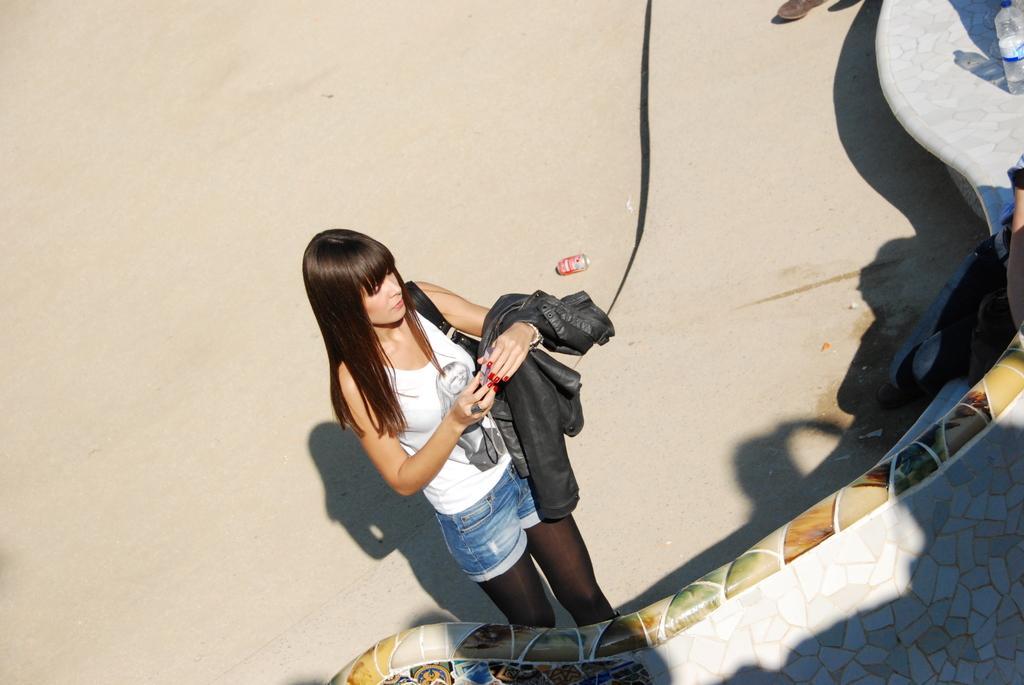Describe this image in one or two sentences. In this picture we can see a woman, black strap and a jacket on her hand. We can see a bottle on a platform. There are a few objects visible on the ground. We can see the shadows of some objects on the ground. 